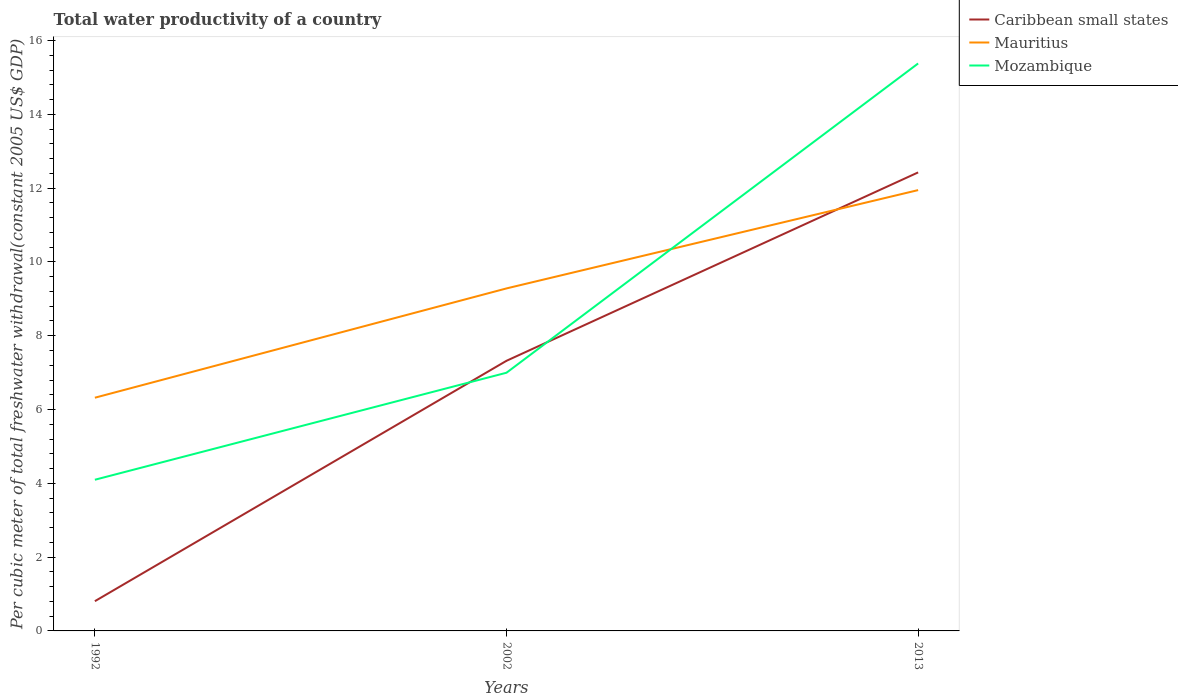Does the line corresponding to Mozambique intersect with the line corresponding to Mauritius?
Provide a short and direct response. Yes. Is the number of lines equal to the number of legend labels?
Your response must be concise. Yes. Across all years, what is the maximum total water productivity in Caribbean small states?
Ensure brevity in your answer.  0.81. What is the total total water productivity in Caribbean small states in the graph?
Keep it short and to the point. -11.62. What is the difference between the highest and the second highest total water productivity in Mauritius?
Provide a short and direct response. 5.63. What is the difference between the highest and the lowest total water productivity in Mozambique?
Keep it short and to the point. 1. Is the total water productivity in Mozambique strictly greater than the total water productivity in Mauritius over the years?
Provide a succinct answer. No. How many lines are there?
Your response must be concise. 3. How many years are there in the graph?
Provide a succinct answer. 3. Does the graph contain any zero values?
Offer a very short reply. No. How many legend labels are there?
Your answer should be very brief. 3. How are the legend labels stacked?
Give a very brief answer. Vertical. What is the title of the graph?
Offer a very short reply. Total water productivity of a country. What is the label or title of the Y-axis?
Ensure brevity in your answer.  Per cubic meter of total freshwater withdrawal(constant 2005 US$ GDP). What is the Per cubic meter of total freshwater withdrawal(constant 2005 US$ GDP) in Caribbean small states in 1992?
Provide a short and direct response. 0.81. What is the Per cubic meter of total freshwater withdrawal(constant 2005 US$ GDP) in Mauritius in 1992?
Ensure brevity in your answer.  6.32. What is the Per cubic meter of total freshwater withdrawal(constant 2005 US$ GDP) of Mozambique in 1992?
Offer a terse response. 4.1. What is the Per cubic meter of total freshwater withdrawal(constant 2005 US$ GDP) of Caribbean small states in 2002?
Provide a short and direct response. 7.32. What is the Per cubic meter of total freshwater withdrawal(constant 2005 US$ GDP) in Mauritius in 2002?
Offer a very short reply. 9.28. What is the Per cubic meter of total freshwater withdrawal(constant 2005 US$ GDP) of Mozambique in 2002?
Your answer should be very brief. 7. What is the Per cubic meter of total freshwater withdrawal(constant 2005 US$ GDP) in Caribbean small states in 2013?
Provide a short and direct response. 12.43. What is the Per cubic meter of total freshwater withdrawal(constant 2005 US$ GDP) of Mauritius in 2013?
Offer a very short reply. 11.95. What is the Per cubic meter of total freshwater withdrawal(constant 2005 US$ GDP) in Mozambique in 2013?
Offer a terse response. 15.38. Across all years, what is the maximum Per cubic meter of total freshwater withdrawal(constant 2005 US$ GDP) in Caribbean small states?
Keep it short and to the point. 12.43. Across all years, what is the maximum Per cubic meter of total freshwater withdrawal(constant 2005 US$ GDP) of Mauritius?
Your response must be concise. 11.95. Across all years, what is the maximum Per cubic meter of total freshwater withdrawal(constant 2005 US$ GDP) in Mozambique?
Keep it short and to the point. 15.38. Across all years, what is the minimum Per cubic meter of total freshwater withdrawal(constant 2005 US$ GDP) of Caribbean small states?
Keep it short and to the point. 0.81. Across all years, what is the minimum Per cubic meter of total freshwater withdrawal(constant 2005 US$ GDP) in Mauritius?
Your answer should be very brief. 6.32. Across all years, what is the minimum Per cubic meter of total freshwater withdrawal(constant 2005 US$ GDP) of Mozambique?
Provide a succinct answer. 4.1. What is the total Per cubic meter of total freshwater withdrawal(constant 2005 US$ GDP) of Caribbean small states in the graph?
Your answer should be compact. 20.55. What is the total Per cubic meter of total freshwater withdrawal(constant 2005 US$ GDP) in Mauritius in the graph?
Ensure brevity in your answer.  27.55. What is the total Per cubic meter of total freshwater withdrawal(constant 2005 US$ GDP) in Mozambique in the graph?
Make the answer very short. 26.47. What is the difference between the Per cubic meter of total freshwater withdrawal(constant 2005 US$ GDP) in Caribbean small states in 1992 and that in 2002?
Give a very brief answer. -6.51. What is the difference between the Per cubic meter of total freshwater withdrawal(constant 2005 US$ GDP) in Mauritius in 1992 and that in 2002?
Offer a terse response. -2.96. What is the difference between the Per cubic meter of total freshwater withdrawal(constant 2005 US$ GDP) in Mozambique in 1992 and that in 2002?
Keep it short and to the point. -2.9. What is the difference between the Per cubic meter of total freshwater withdrawal(constant 2005 US$ GDP) in Caribbean small states in 1992 and that in 2013?
Offer a very short reply. -11.62. What is the difference between the Per cubic meter of total freshwater withdrawal(constant 2005 US$ GDP) of Mauritius in 1992 and that in 2013?
Provide a succinct answer. -5.63. What is the difference between the Per cubic meter of total freshwater withdrawal(constant 2005 US$ GDP) in Mozambique in 1992 and that in 2013?
Give a very brief answer. -11.28. What is the difference between the Per cubic meter of total freshwater withdrawal(constant 2005 US$ GDP) in Caribbean small states in 2002 and that in 2013?
Make the answer very short. -5.11. What is the difference between the Per cubic meter of total freshwater withdrawal(constant 2005 US$ GDP) in Mauritius in 2002 and that in 2013?
Keep it short and to the point. -2.66. What is the difference between the Per cubic meter of total freshwater withdrawal(constant 2005 US$ GDP) in Mozambique in 2002 and that in 2013?
Offer a terse response. -8.38. What is the difference between the Per cubic meter of total freshwater withdrawal(constant 2005 US$ GDP) in Caribbean small states in 1992 and the Per cubic meter of total freshwater withdrawal(constant 2005 US$ GDP) in Mauritius in 2002?
Give a very brief answer. -8.48. What is the difference between the Per cubic meter of total freshwater withdrawal(constant 2005 US$ GDP) in Caribbean small states in 1992 and the Per cubic meter of total freshwater withdrawal(constant 2005 US$ GDP) in Mozambique in 2002?
Give a very brief answer. -6.19. What is the difference between the Per cubic meter of total freshwater withdrawal(constant 2005 US$ GDP) of Mauritius in 1992 and the Per cubic meter of total freshwater withdrawal(constant 2005 US$ GDP) of Mozambique in 2002?
Your response must be concise. -0.68. What is the difference between the Per cubic meter of total freshwater withdrawal(constant 2005 US$ GDP) of Caribbean small states in 1992 and the Per cubic meter of total freshwater withdrawal(constant 2005 US$ GDP) of Mauritius in 2013?
Your answer should be very brief. -11.14. What is the difference between the Per cubic meter of total freshwater withdrawal(constant 2005 US$ GDP) of Caribbean small states in 1992 and the Per cubic meter of total freshwater withdrawal(constant 2005 US$ GDP) of Mozambique in 2013?
Provide a short and direct response. -14.57. What is the difference between the Per cubic meter of total freshwater withdrawal(constant 2005 US$ GDP) of Mauritius in 1992 and the Per cubic meter of total freshwater withdrawal(constant 2005 US$ GDP) of Mozambique in 2013?
Ensure brevity in your answer.  -9.06. What is the difference between the Per cubic meter of total freshwater withdrawal(constant 2005 US$ GDP) of Caribbean small states in 2002 and the Per cubic meter of total freshwater withdrawal(constant 2005 US$ GDP) of Mauritius in 2013?
Your answer should be very brief. -4.63. What is the difference between the Per cubic meter of total freshwater withdrawal(constant 2005 US$ GDP) of Caribbean small states in 2002 and the Per cubic meter of total freshwater withdrawal(constant 2005 US$ GDP) of Mozambique in 2013?
Offer a terse response. -8.06. What is the difference between the Per cubic meter of total freshwater withdrawal(constant 2005 US$ GDP) of Mauritius in 2002 and the Per cubic meter of total freshwater withdrawal(constant 2005 US$ GDP) of Mozambique in 2013?
Keep it short and to the point. -6.1. What is the average Per cubic meter of total freshwater withdrawal(constant 2005 US$ GDP) of Caribbean small states per year?
Offer a very short reply. 6.85. What is the average Per cubic meter of total freshwater withdrawal(constant 2005 US$ GDP) in Mauritius per year?
Offer a terse response. 9.18. What is the average Per cubic meter of total freshwater withdrawal(constant 2005 US$ GDP) in Mozambique per year?
Offer a very short reply. 8.82. In the year 1992, what is the difference between the Per cubic meter of total freshwater withdrawal(constant 2005 US$ GDP) of Caribbean small states and Per cubic meter of total freshwater withdrawal(constant 2005 US$ GDP) of Mauritius?
Ensure brevity in your answer.  -5.51. In the year 1992, what is the difference between the Per cubic meter of total freshwater withdrawal(constant 2005 US$ GDP) of Caribbean small states and Per cubic meter of total freshwater withdrawal(constant 2005 US$ GDP) of Mozambique?
Offer a terse response. -3.29. In the year 1992, what is the difference between the Per cubic meter of total freshwater withdrawal(constant 2005 US$ GDP) in Mauritius and Per cubic meter of total freshwater withdrawal(constant 2005 US$ GDP) in Mozambique?
Provide a short and direct response. 2.22. In the year 2002, what is the difference between the Per cubic meter of total freshwater withdrawal(constant 2005 US$ GDP) in Caribbean small states and Per cubic meter of total freshwater withdrawal(constant 2005 US$ GDP) in Mauritius?
Your answer should be compact. -1.96. In the year 2002, what is the difference between the Per cubic meter of total freshwater withdrawal(constant 2005 US$ GDP) of Caribbean small states and Per cubic meter of total freshwater withdrawal(constant 2005 US$ GDP) of Mozambique?
Offer a very short reply. 0.32. In the year 2002, what is the difference between the Per cubic meter of total freshwater withdrawal(constant 2005 US$ GDP) of Mauritius and Per cubic meter of total freshwater withdrawal(constant 2005 US$ GDP) of Mozambique?
Your answer should be very brief. 2.29. In the year 2013, what is the difference between the Per cubic meter of total freshwater withdrawal(constant 2005 US$ GDP) of Caribbean small states and Per cubic meter of total freshwater withdrawal(constant 2005 US$ GDP) of Mauritius?
Offer a very short reply. 0.48. In the year 2013, what is the difference between the Per cubic meter of total freshwater withdrawal(constant 2005 US$ GDP) of Caribbean small states and Per cubic meter of total freshwater withdrawal(constant 2005 US$ GDP) of Mozambique?
Make the answer very short. -2.95. In the year 2013, what is the difference between the Per cubic meter of total freshwater withdrawal(constant 2005 US$ GDP) of Mauritius and Per cubic meter of total freshwater withdrawal(constant 2005 US$ GDP) of Mozambique?
Your answer should be compact. -3.43. What is the ratio of the Per cubic meter of total freshwater withdrawal(constant 2005 US$ GDP) in Caribbean small states in 1992 to that in 2002?
Keep it short and to the point. 0.11. What is the ratio of the Per cubic meter of total freshwater withdrawal(constant 2005 US$ GDP) of Mauritius in 1992 to that in 2002?
Your answer should be very brief. 0.68. What is the ratio of the Per cubic meter of total freshwater withdrawal(constant 2005 US$ GDP) of Mozambique in 1992 to that in 2002?
Your answer should be very brief. 0.59. What is the ratio of the Per cubic meter of total freshwater withdrawal(constant 2005 US$ GDP) of Caribbean small states in 1992 to that in 2013?
Your response must be concise. 0.06. What is the ratio of the Per cubic meter of total freshwater withdrawal(constant 2005 US$ GDP) of Mauritius in 1992 to that in 2013?
Provide a succinct answer. 0.53. What is the ratio of the Per cubic meter of total freshwater withdrawal(constant 2005 US$ GDP) of Mozambique in 1992 to that in 2013?
Provide a short and direct response. 0.27. What is the ratio of the Per cubic meter of total freshwater withdrawal(constant 2005 US$ GDP) in Caribbean small states in 2002 to that in 2013?
Make the answer very short. 0.59. What is the ratio of the Per cubic meter of total freshwater withdrawal(constant 2005 US$ GDP) of Mauritius in 2002 to that in 2013?
Keep it short and to the point. 0.78. What is the ratio of the Per cubic meter of total freshwater withdrawal(constant 2005 US$ GDP) of Mozambique in 2002 to that in 2013?
Your answer should be compact. 0.46. What is the difference between the highest and the second highest Per cubic meter of total freshwater withdrawal(constant 2005 US$ GDP) in Caribbean small states?
Provide a succinct answer. 5.11. What is the difference between the highest and the second highest Per cubic meter of total freshwater withdrawal(constant 2005 US$ GDP) of Mauritius?
Ensure brevity in your answer.  2.66. What is the difference between the highest and the second highest Per cubic meter of total freshwater withdrawal(constant 2005 US$ GDP) in Mozambique?
Keep it short and to the point. 8.38. What is the difference between the highest and the lowest Per cubic meter of total freshwater withdrawal(constant 2005 US$ GDP) in Caribbean small states?
Give a very brief answer. 11.62. What is the difference between the highest and the lowest Per cubic meter of total freshwater withdrawal(constant 2005 US$ GDP) of Mauritius?
Make the answer very short. 5.63. What is the difference between the highest and the lowest Per cubic meter of total freshwater withdrawal(constant 2005 US$ GDP) of Mozambique?
Offer a very short reply. 11.28. 